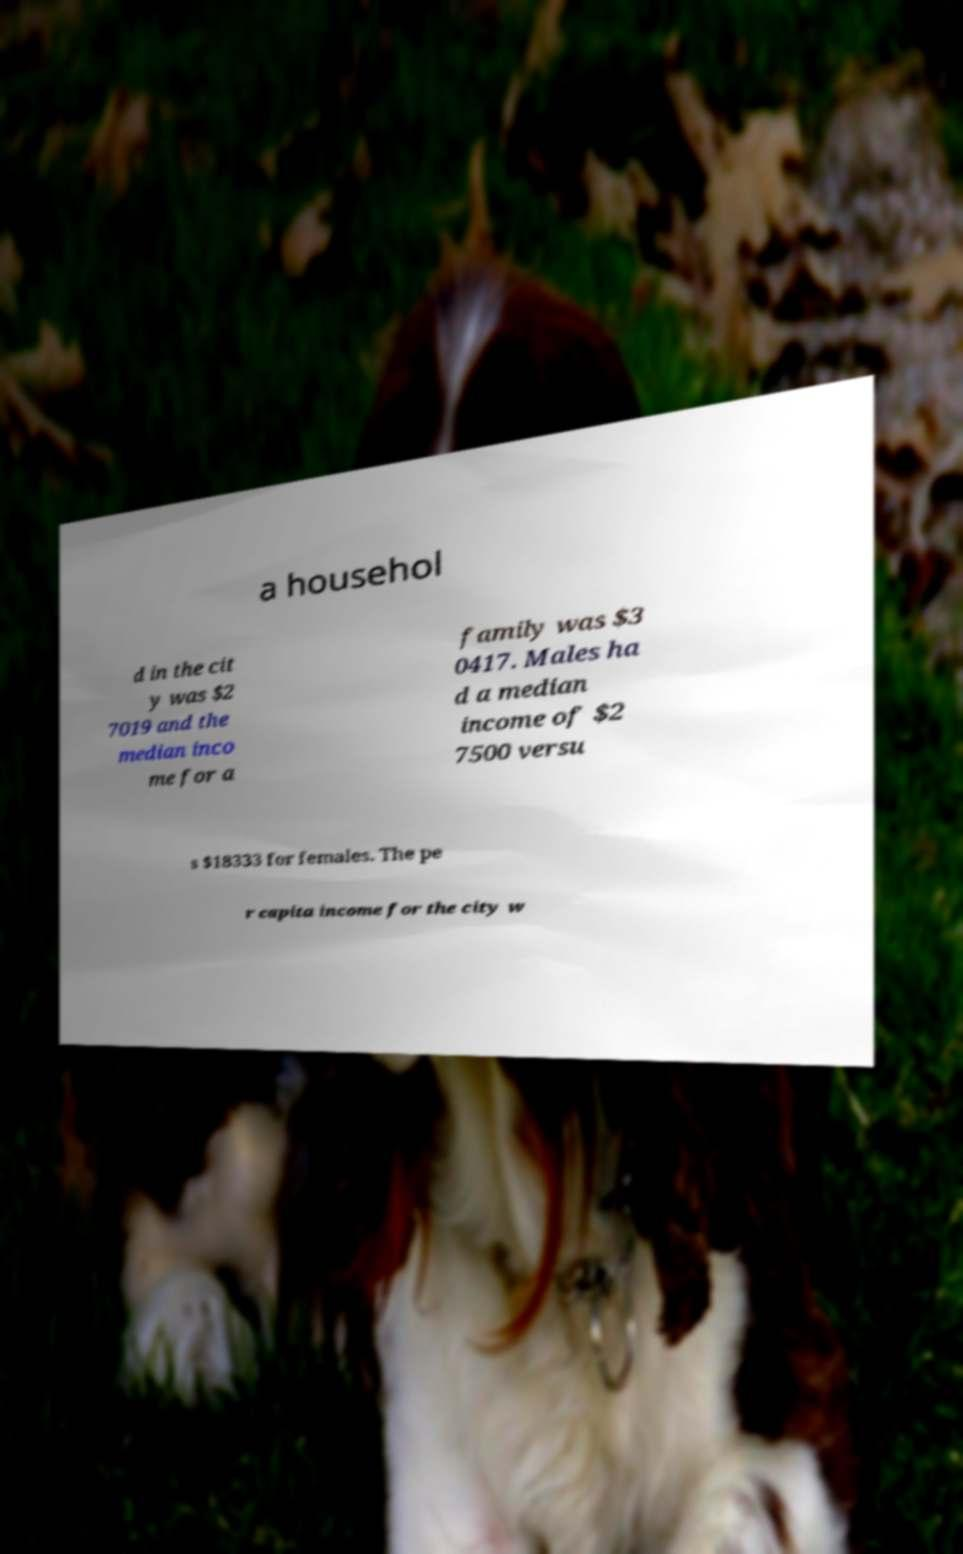Could you extract and type out the text from this image? a househol d in the cit y was $2 7019 and the median inco me for a family was $3 0417. Males ha d a median income of $2 7500 versu s $18333 for females. The pe r capita income for the city w 